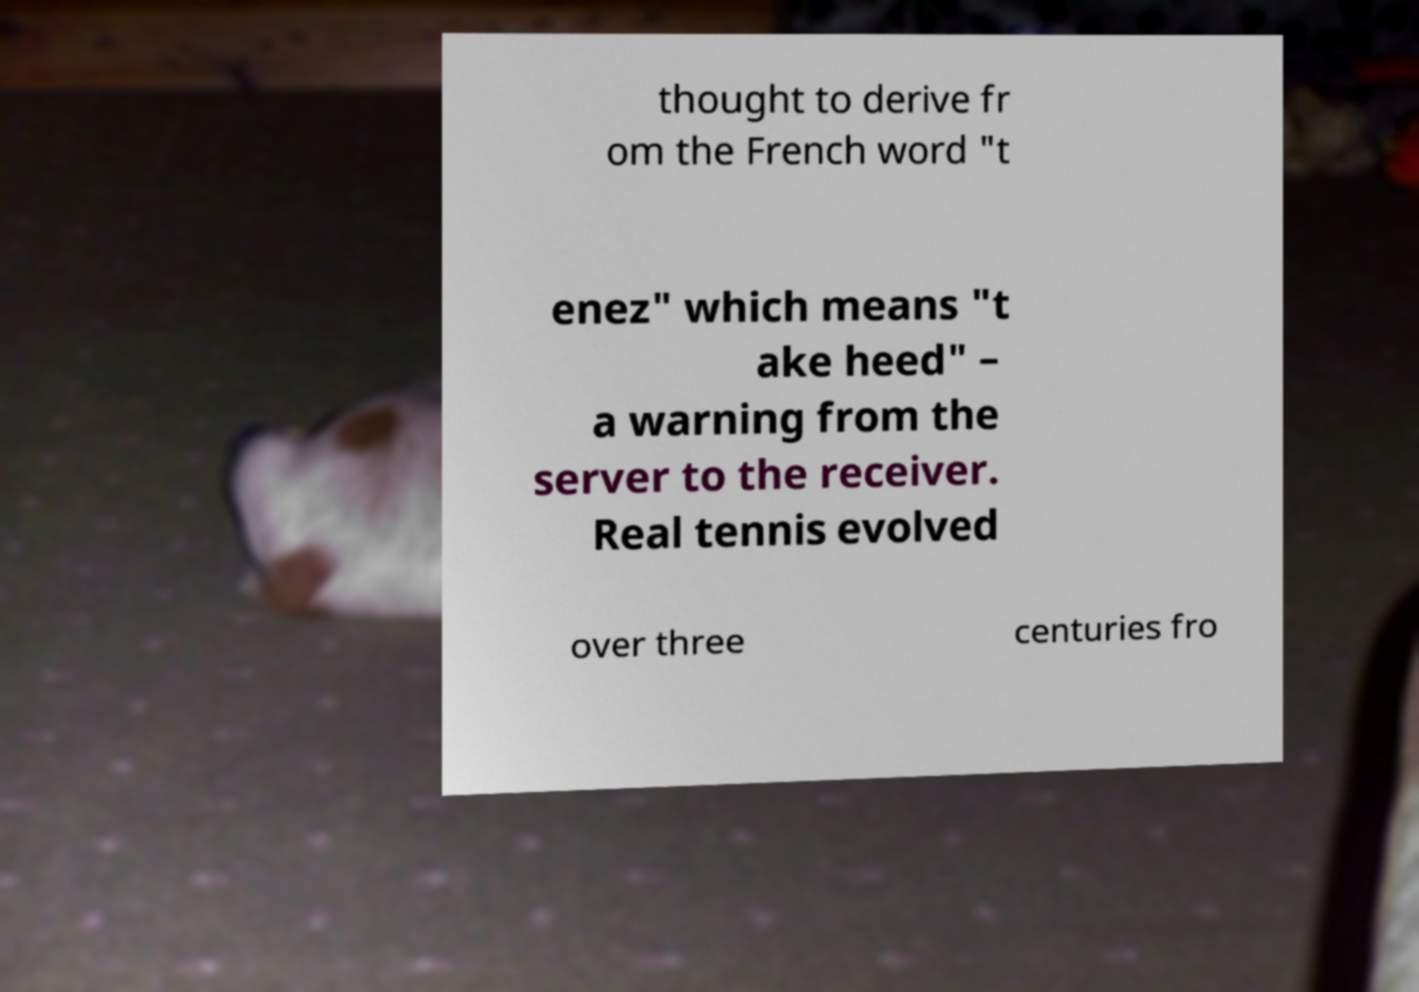Please read and relay the text visible in this image. What does it say? thought to derive fr om the French word "t enez" which means "t ake heed" – a warning from the server to the receiver. Real tennis evolved over three centuries fro 